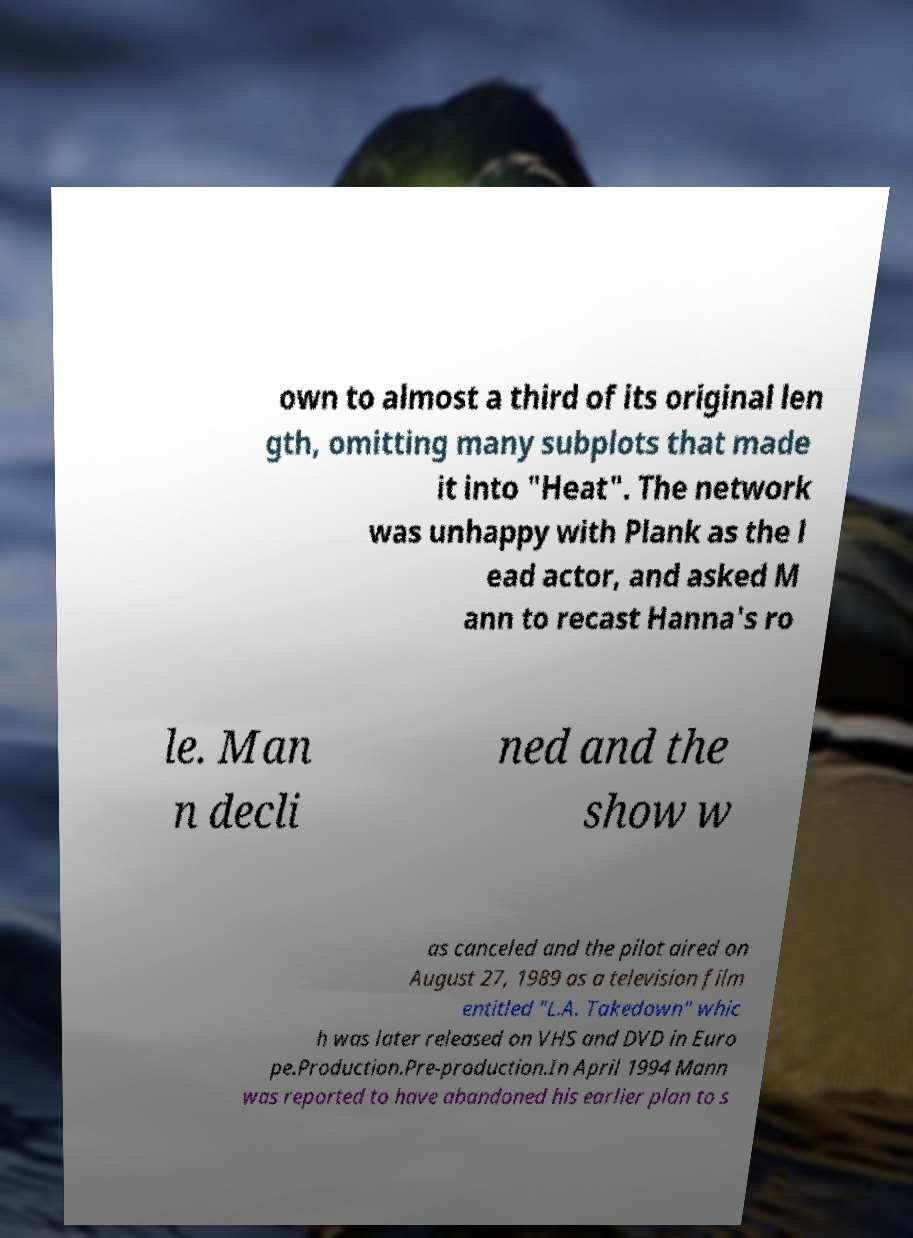Can you read and provide the text displayed in the image?This photo seems to have some interesting text. Can you extract and type it out for me? own to almost a third of its original len gth, omitting many subplots that made it into "Heat". The network was unhappy with Plank as the l ead actor, and asked M ann to recast Hanna's ro le. Man n decli ned and the show w as canceled and the pilot aired on August 27, 1989 as a television film entitled "L.A. Takedown" whic h was later released on VHS and DVD in Euro pe.Production.Pre-production.In April 1994 Mann was reported to have abandoned his earlier plan to s 